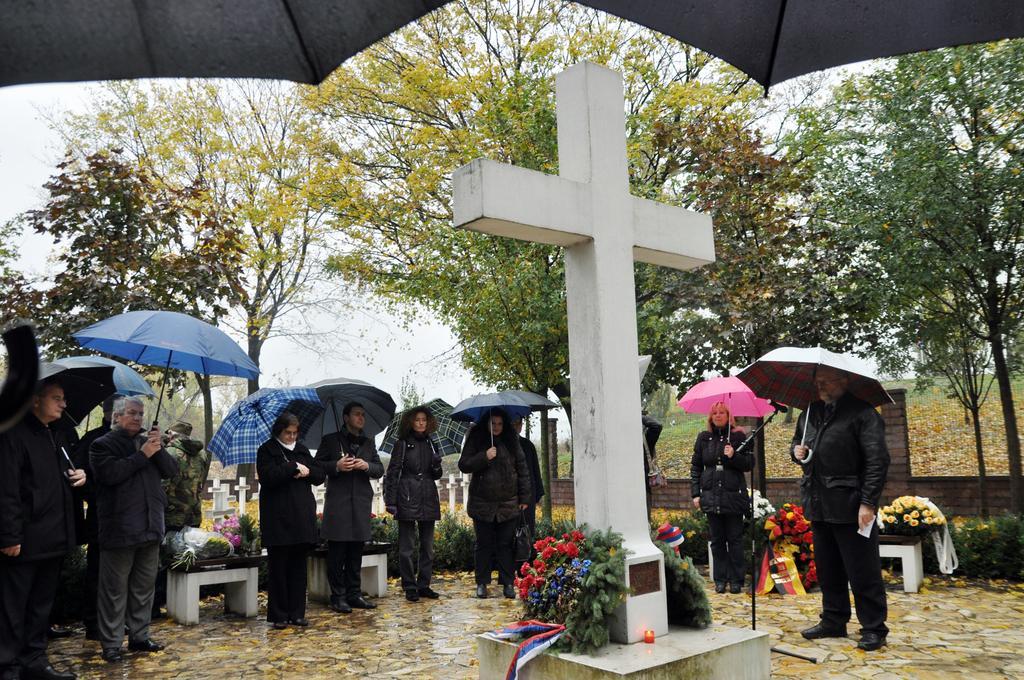Please provide a concise description of this image. In this picture we can see some people standing here, they are holding umbrellas, we can see plants and trees in the background, there are some flowers here, we can see Christianity symbol here, there is the sky at the top of the picture. 